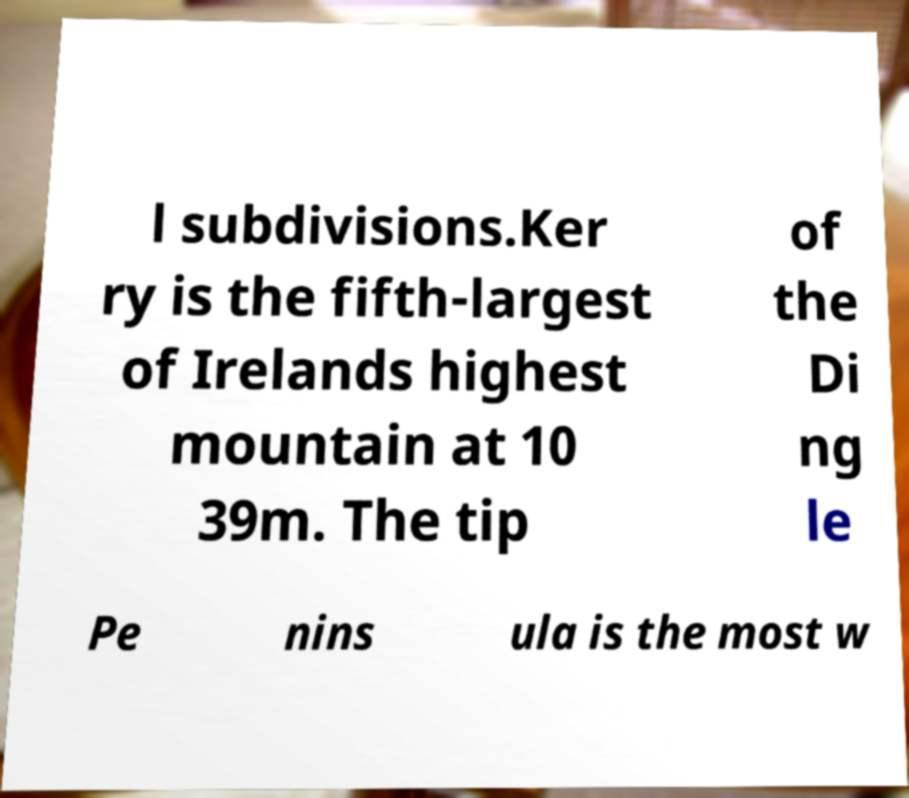What messages or text are displayed in this image? I need them in a readable, typed format. l subdivisions.Ker ry is the fifth-largest of Irelands highest mountain at 10 39m. The tip of the Di ng le Pe nins ula is the most w 